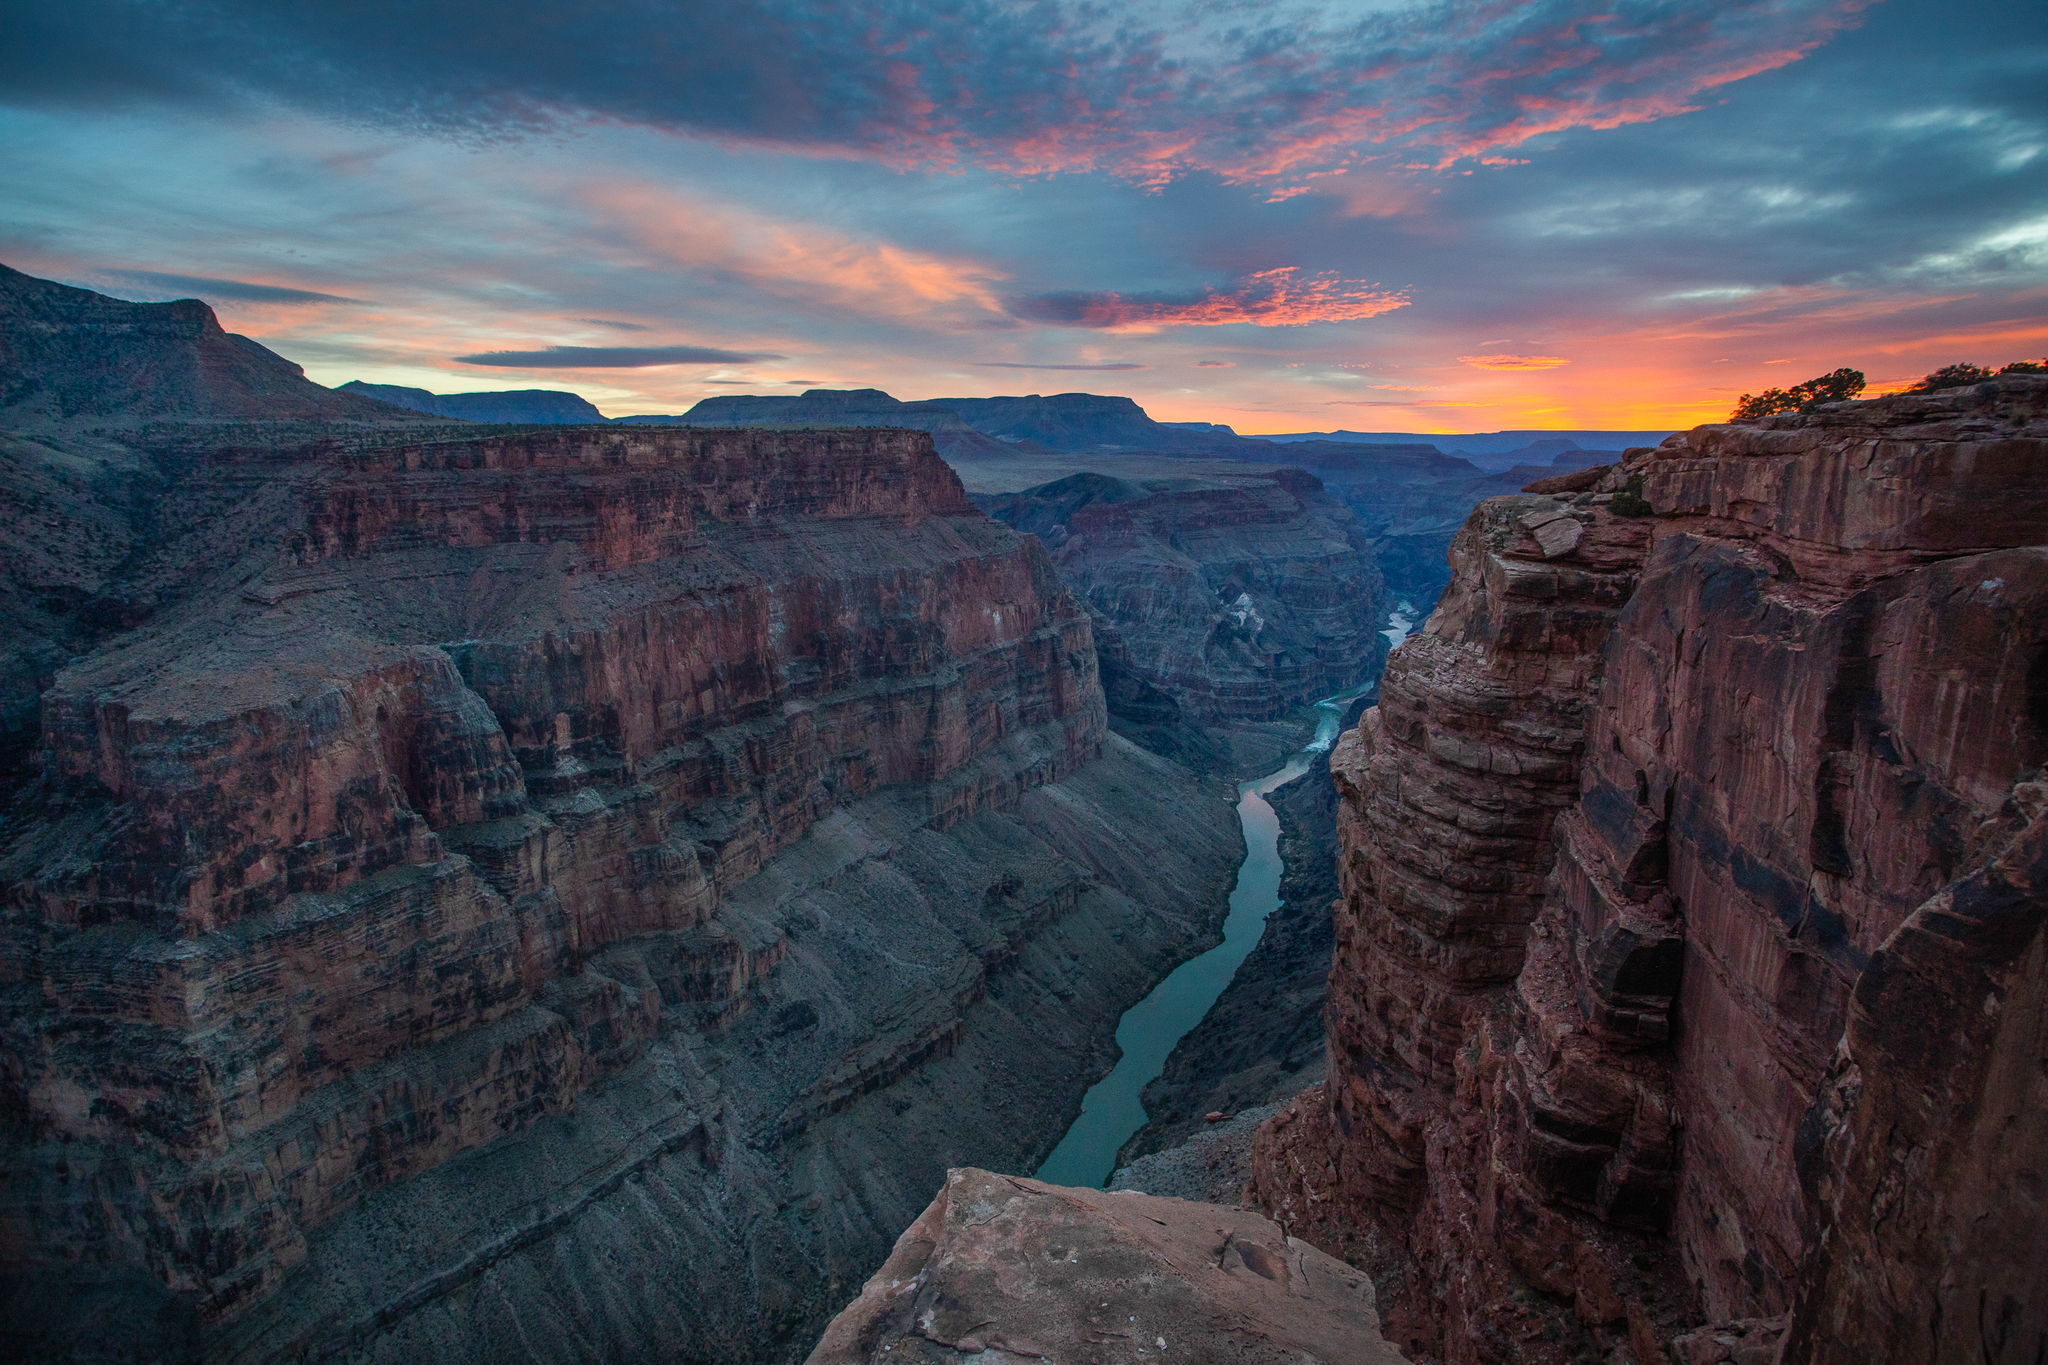How has the Colorado River shaped the formation of the Grand Canyon? The Colorado River has played a crucial role in carving the Grand Canyon over approximately 5 to 6 million years. Its relentless flow eroded the rock layer by layer, exploiting and widening natural fractures, and washing sediments downstream. Over millennia, this process deepened and widened the canyon, creating the vast and deep geographical wonder we see today. The river essentially sculpted the canyon's steep walls and dramatic cliff-faces, showcasing one of the most dynamic examples of water reshaping the landscape. 